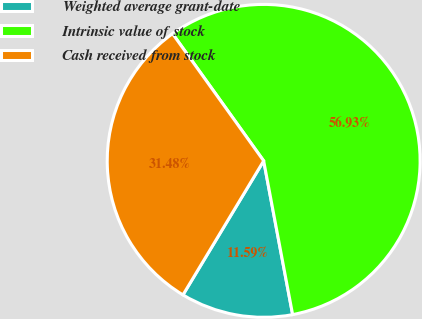Convert chart. <chart><loc_0><loc_0><loc_500><loc_500><pie_chart><fcel>Weighted average grant-date<fcel>Intrinsic value of stock<fcel>Cash received from stock<nl><fcel>11.59%<fcel>56.93%<fcel>31.48%<nl></chart> 